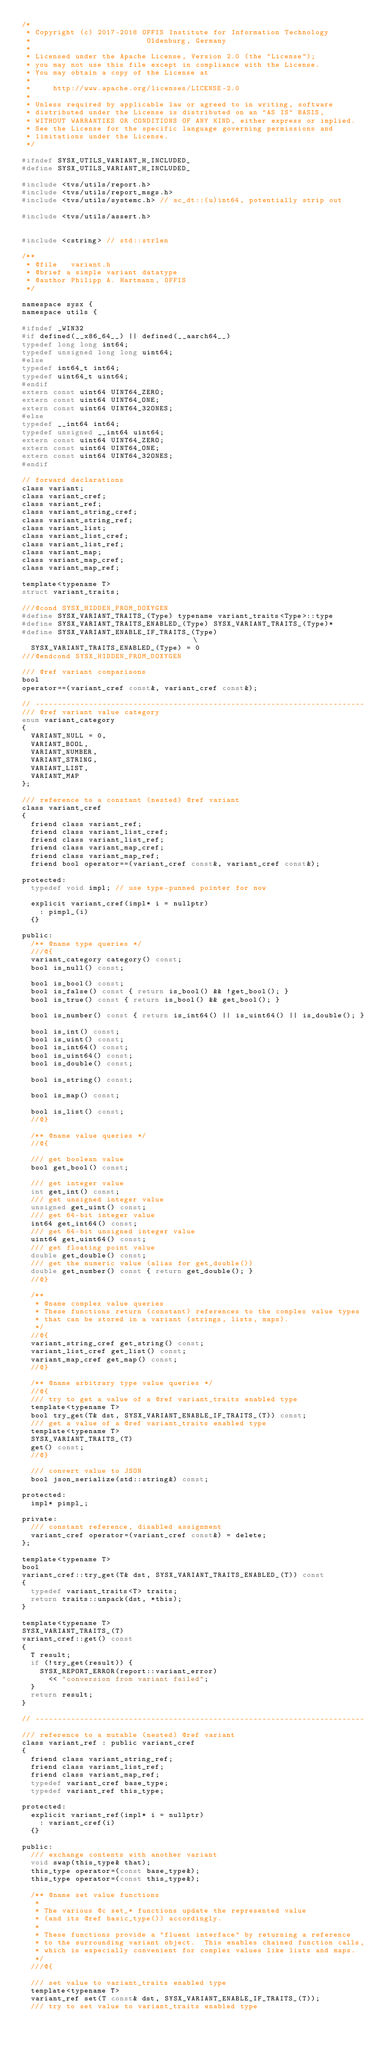<code> <loc_0><loc_0><loc_500><loc_500><_C_>/*
 * Copyright (c) 2017-2018 OFFIS Institute for Information Technology
 *                          Oldenburg, Germany
 *
 * Licensed under the Apache License, Version 2.0 (the "License");
 * you may not use this file except in compliance with the License.
 * You may obtain a copy of the License at
 *
 *     http://www.apache.org/licenses/LICENSE-2.0
 *
 * Unless required by applicable law or agreed to in writing, software
 * distributed under the License is distributed on an "AS IS" BASIS,
 * WITHOUT WARRANTIES OR CONDITIONS OF ANY KIND, either express or implied.
 * See the License for the specific language governing permissions and
 * limitations under the License.
 */

#ifndef SYSX_UTILS_VARIANT_H_INCLUDED_
#define SYSX_UTILS_VARIANT_H_INCLUDED_

#include <tvs/utils/report.h>
#include <tvs/utils/report_msgs.h>
#include <tvs/utils/systemc.h> // sc_dt::(u)int64, potentially strip out

#include <tvs/utils/assert.h>


#include <cstring> // std::strlen

/**
 * @file   variant.h
 * @brief a simple variant datatype
 * @author Philipp A. Hartmann, OFFIS
 */

namespace sysx {
namespace utils {

#ifndef _WIN32
#if defined(__x86_64__) || defined(__aarch64__)
typedef long long int64;
typedef unsigned long long uint64;
#else
typedef int64_t int64;
typedef uint64_t uint64;
#endif
extern const uint64 UINT64_ZERO;
extern const uint64 UINT64_ONE;
extern const uint64 UINT64_32ONES;
#else
typedef __int64 int64;
typedef unsigned __int64 uint64;
extern const uint64 UINT64_ZERO;
extern const uint64 UINT64_ONE;
extern const uint64 UINT64_32ONES;
#endif

// forward declarations
class variant;
class variant_cref;
class variant_ref;
class variant_string_cref;
class variant_string_ref;
class variant_list;
class variant_list_cref;
class variant_list_ref;
class variant_map;
class variant_map_cref;
class variant_map_ref;

template<typename T>
struct variant_traits;

///@cond SYSX_HIDDEN_FROM_DOXYGEN
#define SYSX_VARIANT_TRAITS_(Type) typename variant_traits<Type>::type
#define SYSX_VARIANT_TRAITS_ENABLED_(Type) SYSX_VARIANT_TRAITS_(Type)*
#define SYSX_VARIANT_ENABLE_IF_TRAITS_(Type)                                   \
  SYSX_VARIANT_TRAITS_ENABLED_(Type) = 0
///@endcond SYSX_HIDDEN_FROM_DOXYGEN

/// @ref variant comparisons
bool
operator==(variant_cref const&, variant_cref const&);

// --------------------------------------------------------------------------
/// @ref variant value category
enum variant_category
{
  VARIANT_NULL = 0,
  VARIANT_BOOL,
  VARIANT_NUMBER,
  VARIANT_STRING,
  VARIANT_LIST,
  VARIANT_MAP
};

/// reference to a constant (nested) @ref variant
class variant_cref
{
  friend class variant_ref;
  friend class variant_list_cref;
  friend class variant_list_ref;
  friend class variant_map_cref;
  friend class variant_map_ref;
  friend bool operator==(variant_cref const&, variant_cref const&);

protected:
  typedef void impl; // use type-punned pointer for now

  explicit variant_cref(impl* i = nullptr)
    : pimpl_(i)
  {}

public:
  /** @name type queries */
  ///@{
  variant_category category() const;
  bool is_null() const;

  bool is_bool() const;
  bool is_false() const { return is_bool() && !get_bool(); }
  bool is_true() const { return is_bool() && get_bool(); }

  bool is_number() const { return is_int64() || is_uint64() || is_double(); }

  bool is_int() const;
  bool is_uint() const;
  bool is_int64() const;
  bool is_uint64() const;
  bool is_double() const;

  bool is_string() const;

  bool is_map() const;

  bool is_list() const;
  //@}

  /** @name value queries */
  //@{

  /// get boolean value
  bool get_bool() const;

  /// get integer value
  int get_int() const;
  /// get unsigned integer value
  unsigned get_uint() const;
  /// get 64-bit integer value
  int64 get_int64() const;
  /// get 64-bit unsigned integer value
  uint64 get_uint64() const;
  /// get floating point value
  double get_double() const;
  /// get the numeric value (alias for get_double())
  double get_number() const { return get_double(); }
  //@}

  /**
   * @name complex value queries
   * These functions return (constant) references to the complex value types
   * that can be stored in a variant (strings, lists, maps).
   */
  //@{
  variant_string_cref get_string() const;
  variant_list_cref get_list() const;
  variant_map_cref get_map() const;
  //@}

  /** @name arbitrary type value queries */
  //@{
  /// try to get a value of a @ref variant_traits enabled type
  template<typename T>
  bool try_get(T& dst, SYSX_VARIANT_ENABLE_IF_TRAITS_(T)) const;
  /// get a value of a @ref variant_traits enabled type
  template<typename T>
  SYSX_VARIANT_TRAITS_(T)
  get() const;
  //@}

  /// convert value to JSON
  bool json_serialize(std::string&) const;

protected:
  impl* pimpl_;

private:
  /// constant reference, disabled assignment
  variant_cref operator=(variant_cref const&) = delete;
};

template<typename T>
bool
variant_cref::try_get(T& dst, SYSX_VARIANT_TRAITS_ENABLED_(T)) const
{
  typedef variant_traits<T> traits;
  return traits::unpack(dst, *this);
}

template<typename T>
SYSX_VARIANT_TRAITS_(T)
variant_cref::get() const
{
  T result;
  if (!try_get(result)) {
    SYSX_REPORT_ERROR(report::variant_error)
      << "conversion from variant failed";
  }
  return result;
}

// --------------------------------------------------------------------------

/// reference to a mutable (nested) @ref variant
class variant_ref : public variant_cref
{
  friend class variant_string_ref;
  friend class variant_list_ref;
  friend class variant_map_ref;
  typedef variant_cref base_type;
  typedef variant_ref this_type;

protected:
  explicit variant_ref(impl* i = nullptr)
    : variant_cref(i)
  {}

public:
  /// exchange contents with another variant
  void swap(this_type& that);
  this_type operator=(const base_type&);
  this_type operator=(const this_type&);

  /** @name set value functions
   *
   * The various @c set_* functions update the represented value
   * (and its @ref basic_type()) accordingly.
   *
   * These functions provide a "fluent interface" by returning a reference
   * to the surrounding variant object.  This enables chained function calls,
   * which is especially convenient for complex values like lists and maps.
   */
  ///@{

  /// set value to variant_traits enabled type
  template<typename T>
  variant_ref set(T const& dst, SYSX_VARIANT_ENABLE_IF_TRAITS_(T));
  /// try to set value to variant_traits enabled type</code> 